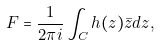<formula> <loc_0><loc_0><loc_500><loc_500>F = \frac { 1 } { 2 \pi i } \int _ { C } h ( z ) \bar { z } d z ,</formula> 